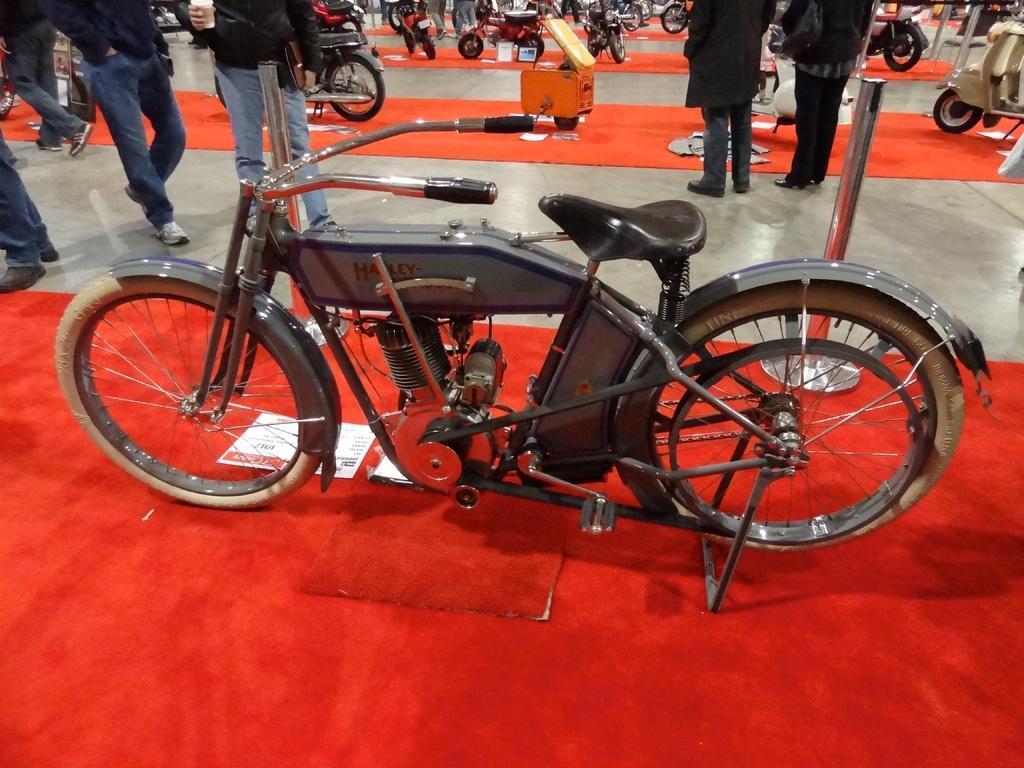Could you give a brief overview of what you see in this image? In this image I can see number of carpets on the floor and on it I can see number of vehicles. I can also see number of moles and number of people are standing. On the top side of this image I can see an orange colour thing and in the center I can see a white colour board on the carpet. 